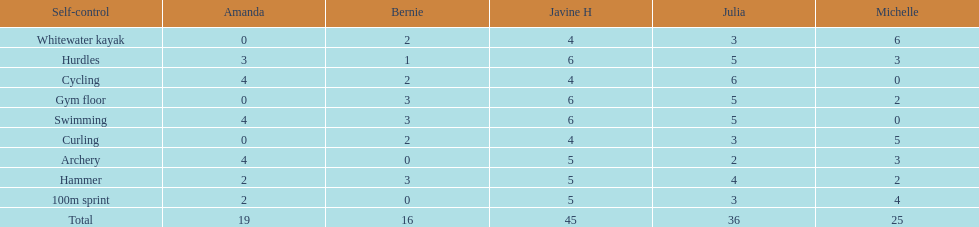Who earned the most total points? Javine H. Help me parse the entirety of this table. {'header': ['Self-control', 'Amanda', 'Bernie', 'Javine H', 'Julia', 'Michelle'], 'rows': [['Whitewater kayak', '0', '2', '4', '3', '6'], ['Hurdles', '3', '1', '6', '5', '3'], ['Cycling', '4', '2', '4', '6', '0'], ['Gym floor', '0', '3', '6', '5', '2'], ['Swimming', '4', '3', '6', '5', '0'], ['Curling', '0', '2', '4', '3', '5'], ['Archery', '4', '0', '5', '2', '3'], ['Hammer', '2', '3', '5', '4', '2'], ['100m sprint', '2', '0', '5', '3', '4'], ['Total', '19', '16', '45', '36', '25']]} 